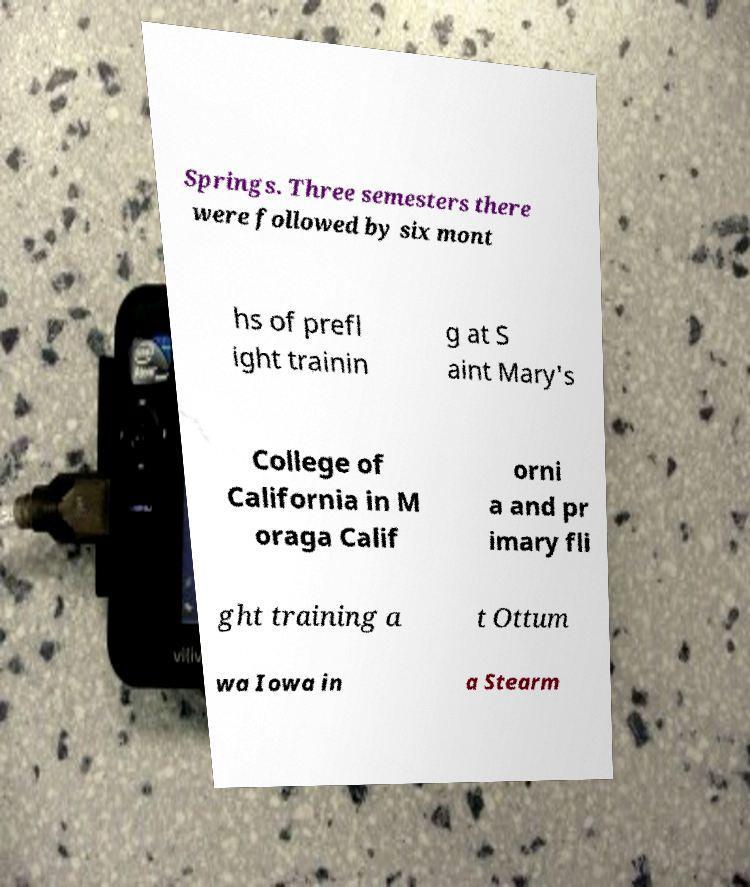I need the written content from this picture converted into text. Can you do that? Springs. Three semesters there were followed by six mont hs of prefl ight trainin g at S aint Mary's College of California in M oraga Calif orni a and pr imary fli ght training a t Ottum wa Iowa in a Stearm 